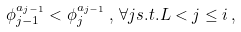Convert formula to latex. <formula><loc_0><loc_0><loc_500><loc_500>\phi ^ { a _ { j - 1 } } _ { j - 1 } < \phi ^ { a _ { j - 1 } } _ { j } \, , \, \forall j s . t . L < j \leq i \, ,</formula> 